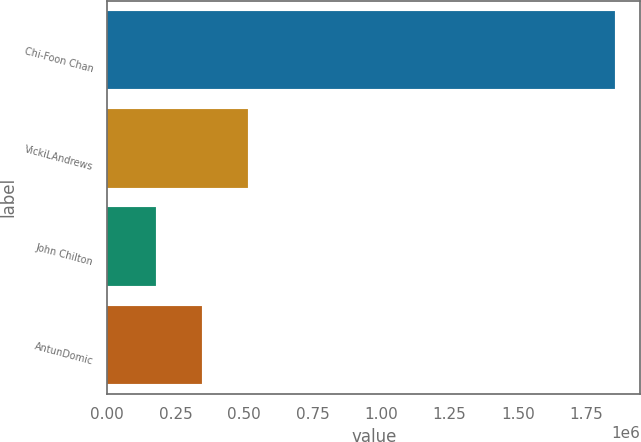<chart> <loc_0><loc_0><loc_500><loc_500><bar_chart><fcel>Chi-Foon Chan<fcel>VickiLAndrews<fcel>John Chilton<fcel>AntunDomic<nl><fcel>1.85528e+06<fcel>513318<fcel>177828<fcel>345573<nl></chart> 